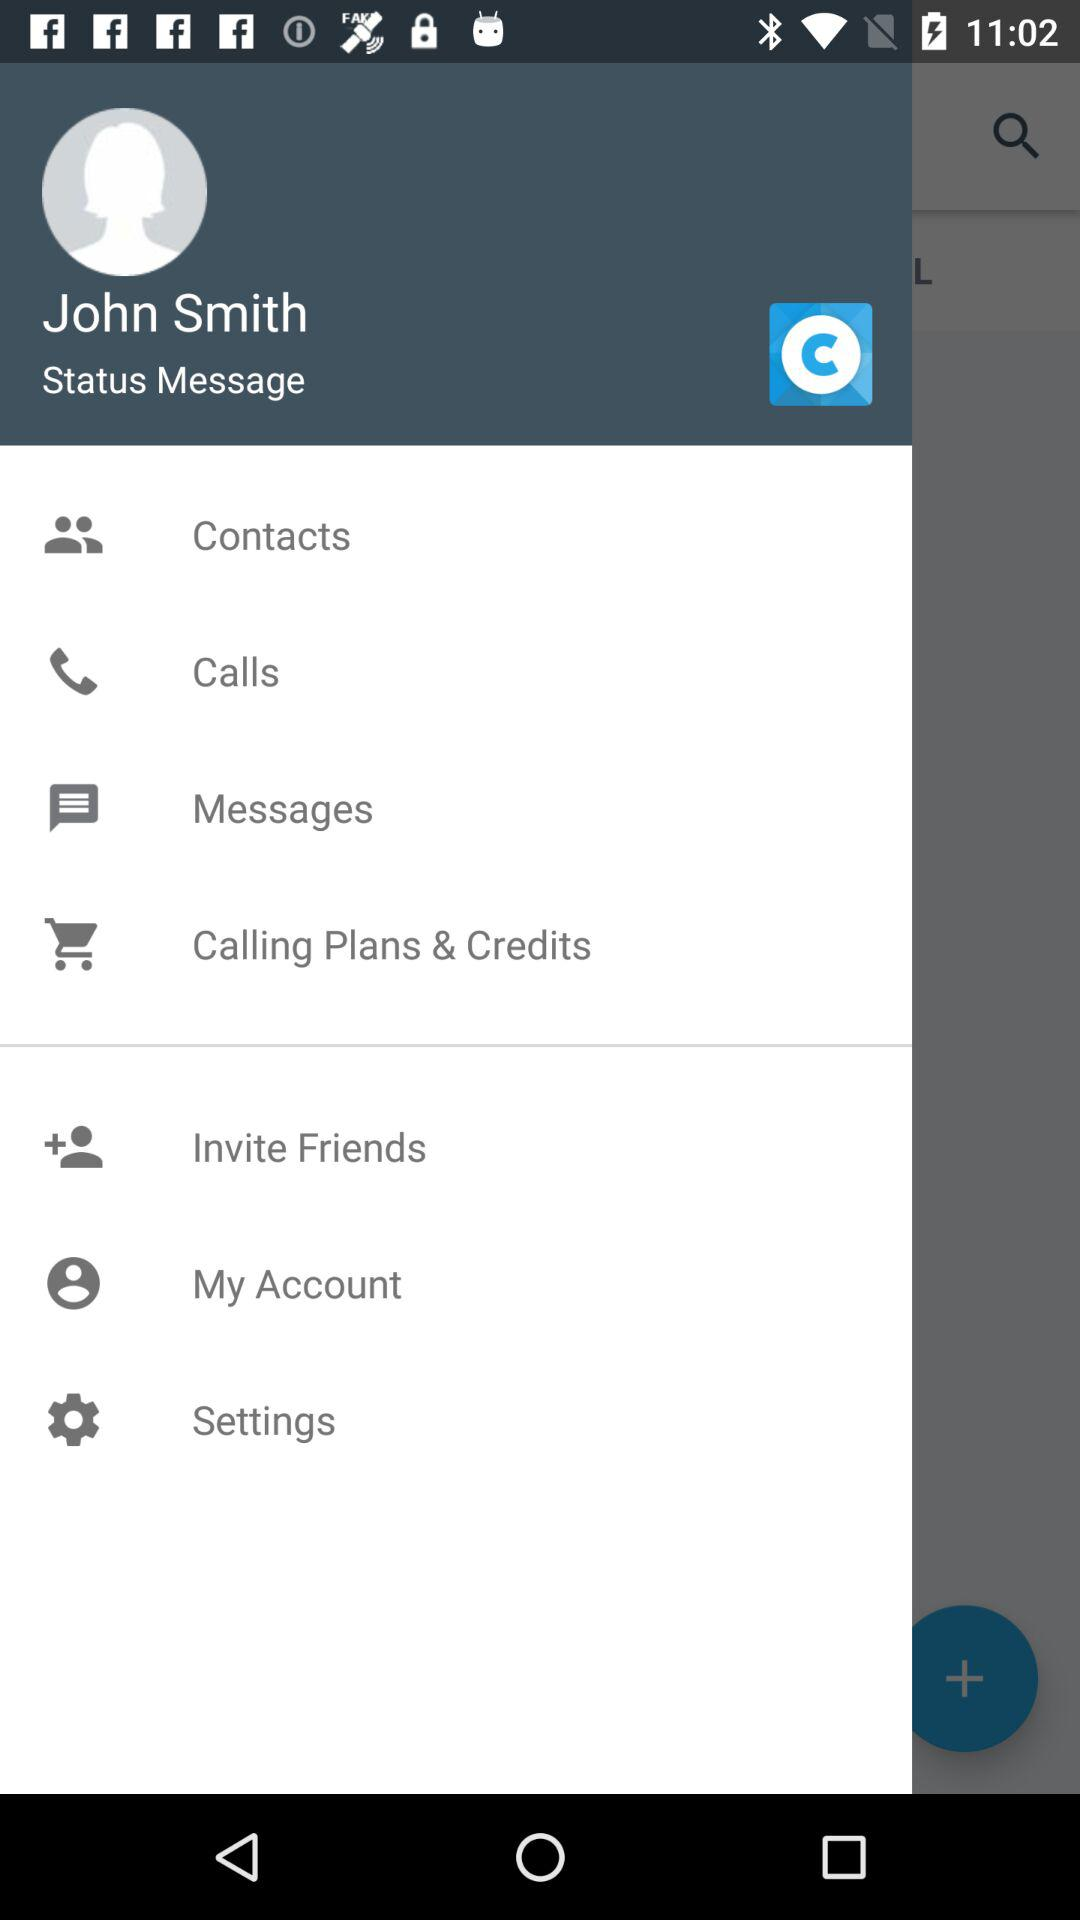What is the user name? The user name is John Smith. 